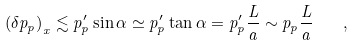<formula> <loc_0><loc_0><loc_500><loc_500>\left ( \delta p _ { p } \right ) _ { x } \lesssim p _ { p } ^ { \prime } \sin \alpha \simeq p _ { p } ^ { \prime } \tan \alpha = p _ { p } ^ { \prime } \frac { L } { a } \sim p _ { p } \frac { L } { a } \quad ,</formula> 